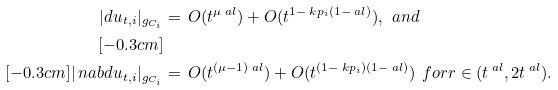<formula> <loc_0><loc_0><loc_500><loc_500>| d u _ { t , i } | _ { g _ { C _ { i } } } & = \, O ( t ^ { \mu \ a l } ) + O ( t ^ { 1 - \ k p _ { i } ( 1 - \ a l ) } ) , \ \ a n d \\ [ - 0 . 3 c m ] \\ [ - 0 . 3 c m ] | \ n a b d u _ { t , i } | _ { g _ { C _ { i } } } & = \, O ( t ^ { ( \mu - 1 ) \ a l } ) + O ( t ^ { ( 1 - \ k p _ { i } ) ( 1 - \ a l ) } ) \ \ f o r r \in ( t ^ { \ a l } , 2 t ^ { \ a l } ) .</formula> 